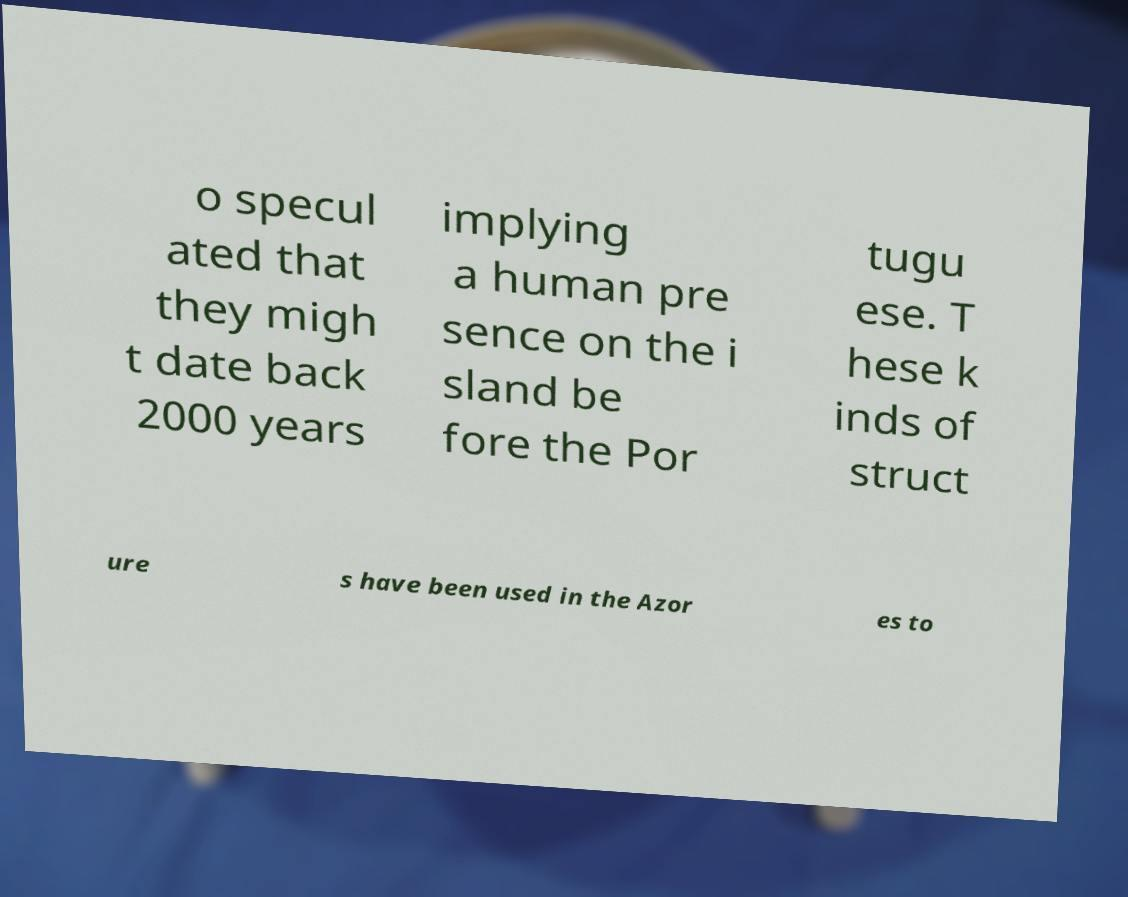Please read and relay the text visible in this image. What does it say? o specul ated that they migh t date back 2000 years implying a human pre sence on the i sland be fore the Por tugu ese. T hese k inds of struct ure s have been used in the Azor es to 